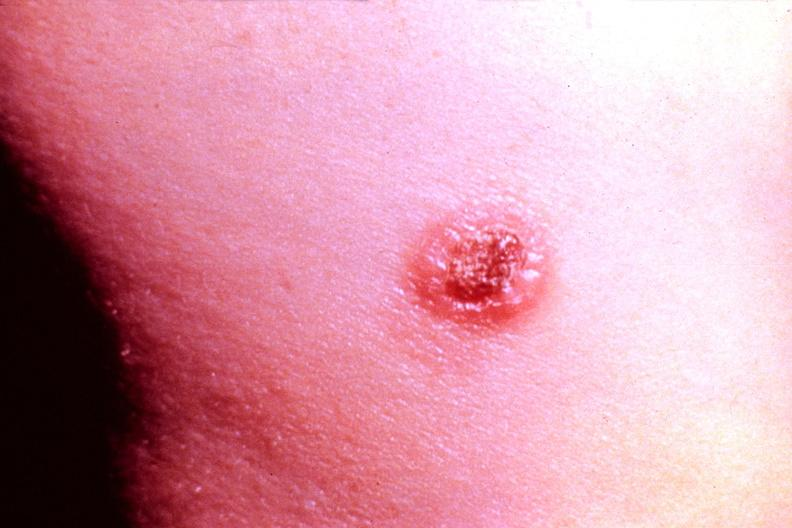does this image show cryptococcal dematitis?
Answer the question using a single word or phrase. Yes 